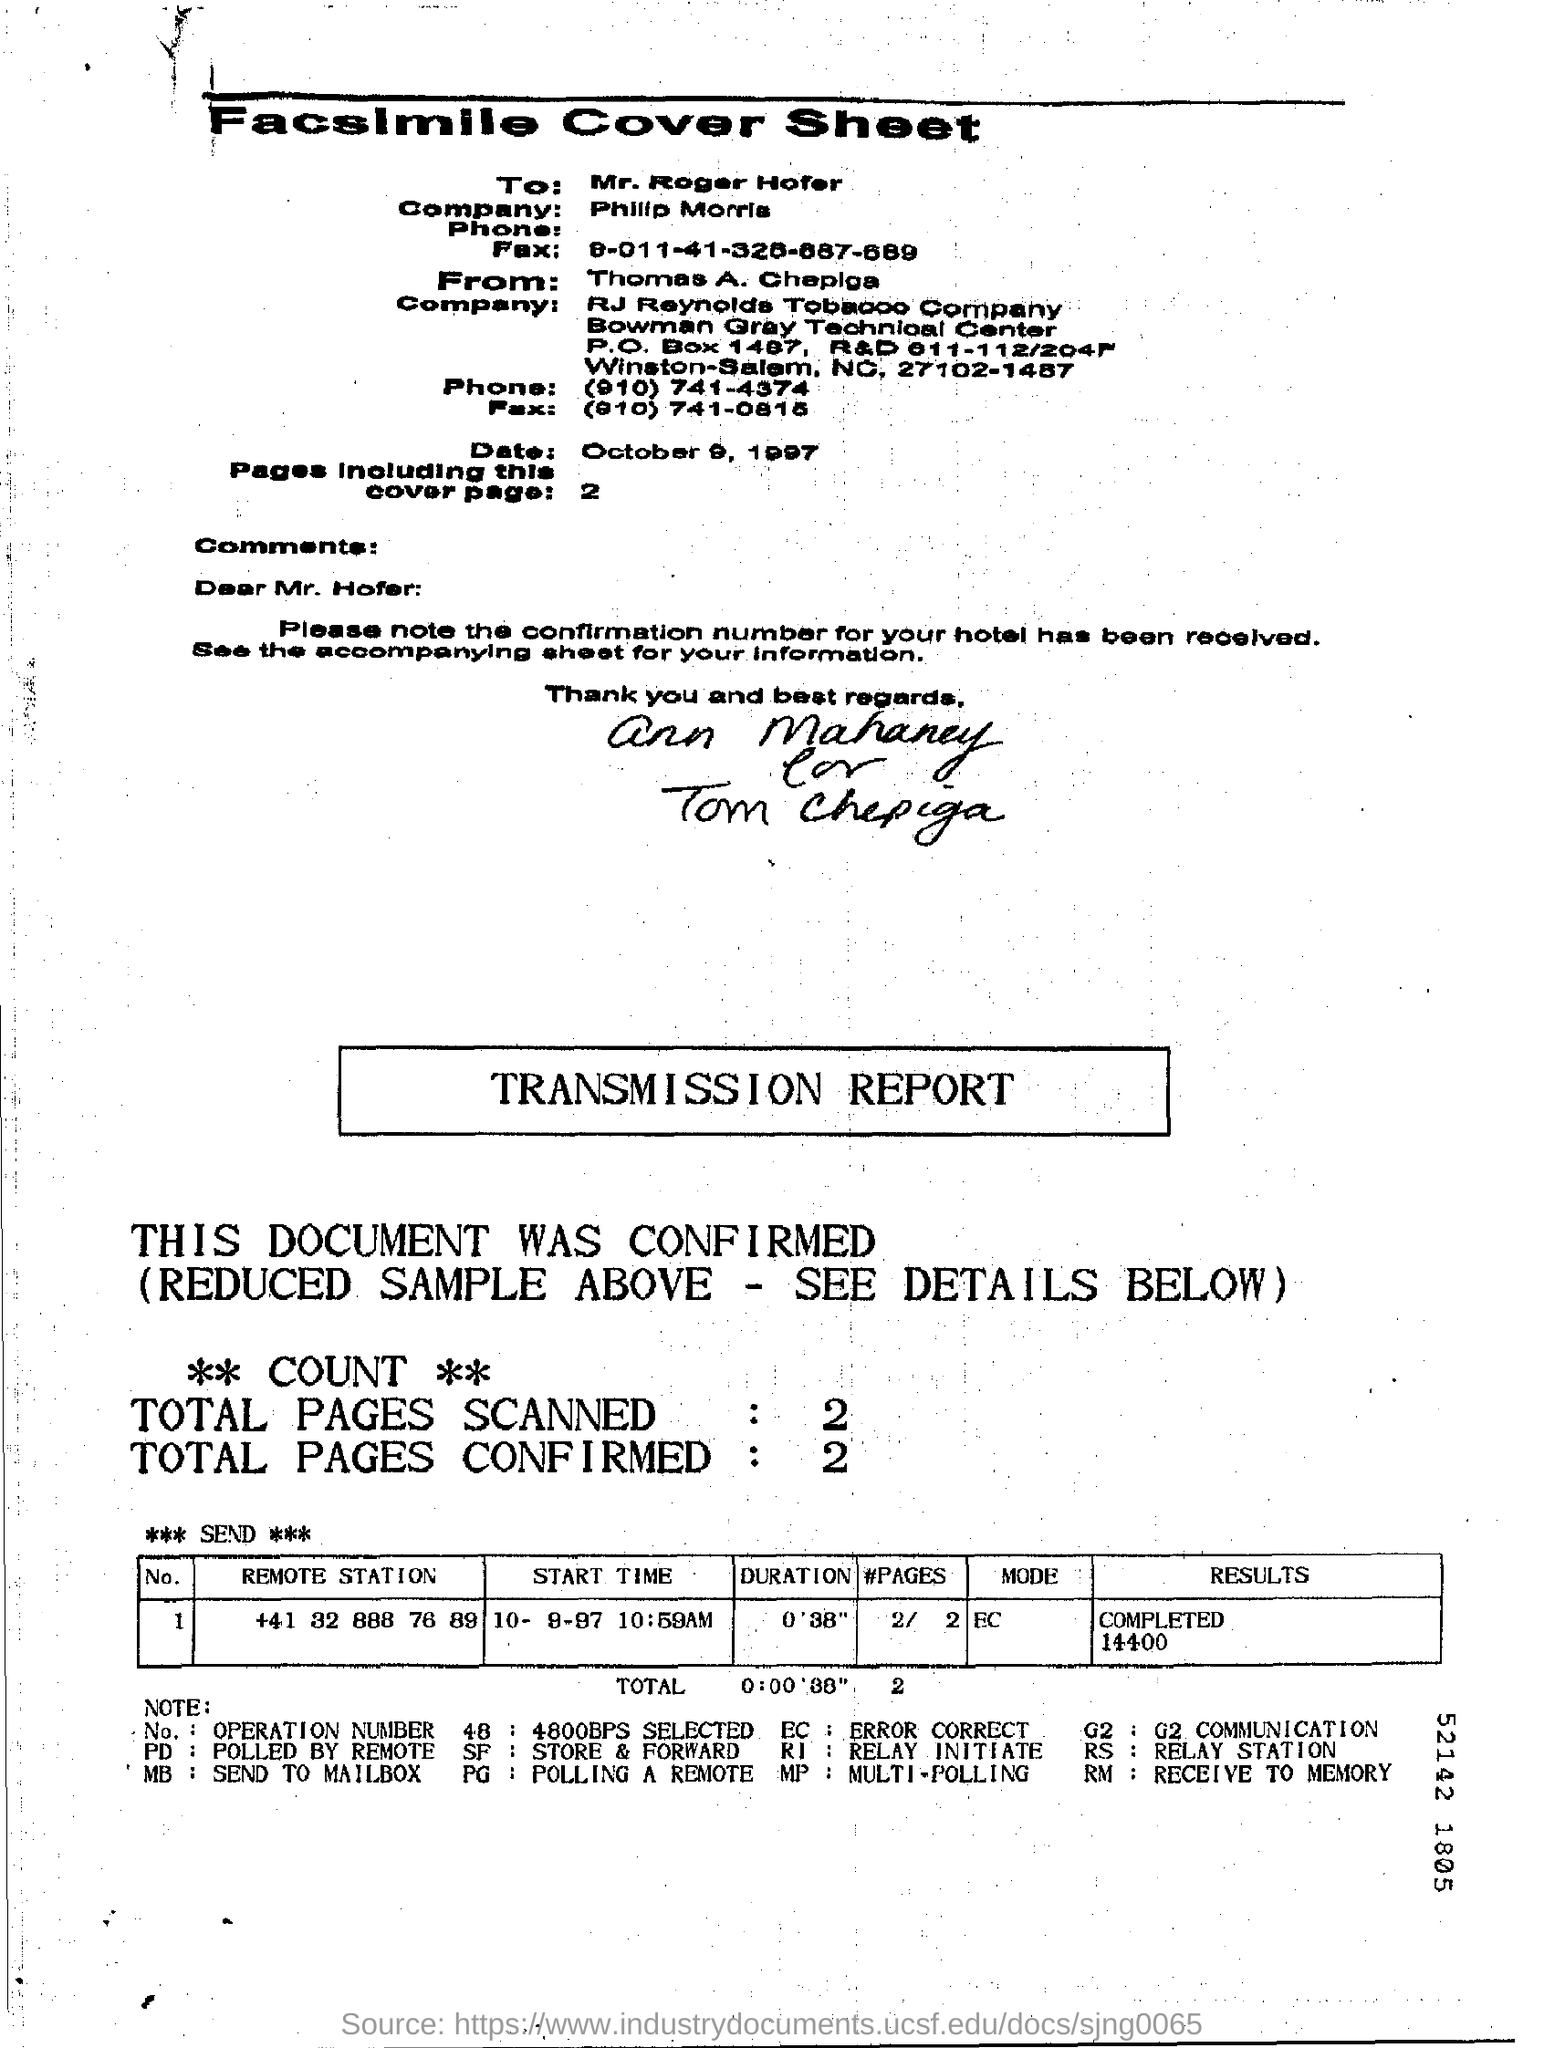What are the total number of pages SCANNED?
Give a very brief answer. 2 Pages. What is the name of the company of Mr. Roger  Hofer?
Provide a succinct answer. Philip Morris. What is the date mentioned in the top half of the document?
Offer a very short reply. October 9, 1997. 